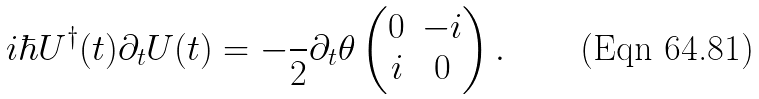Convert formula to latex. <formula><loc_0><loc_0><loc_500><loc_500>i \hbar { U } ^ { \dag } ( t ) \partial _ { t } U ( t ) = - \frac { } { 2 } \partial _ { t } \theta \begin{pmatrix} 0 & - i \\ i & 0 \end{pmatrix} .</formula> 